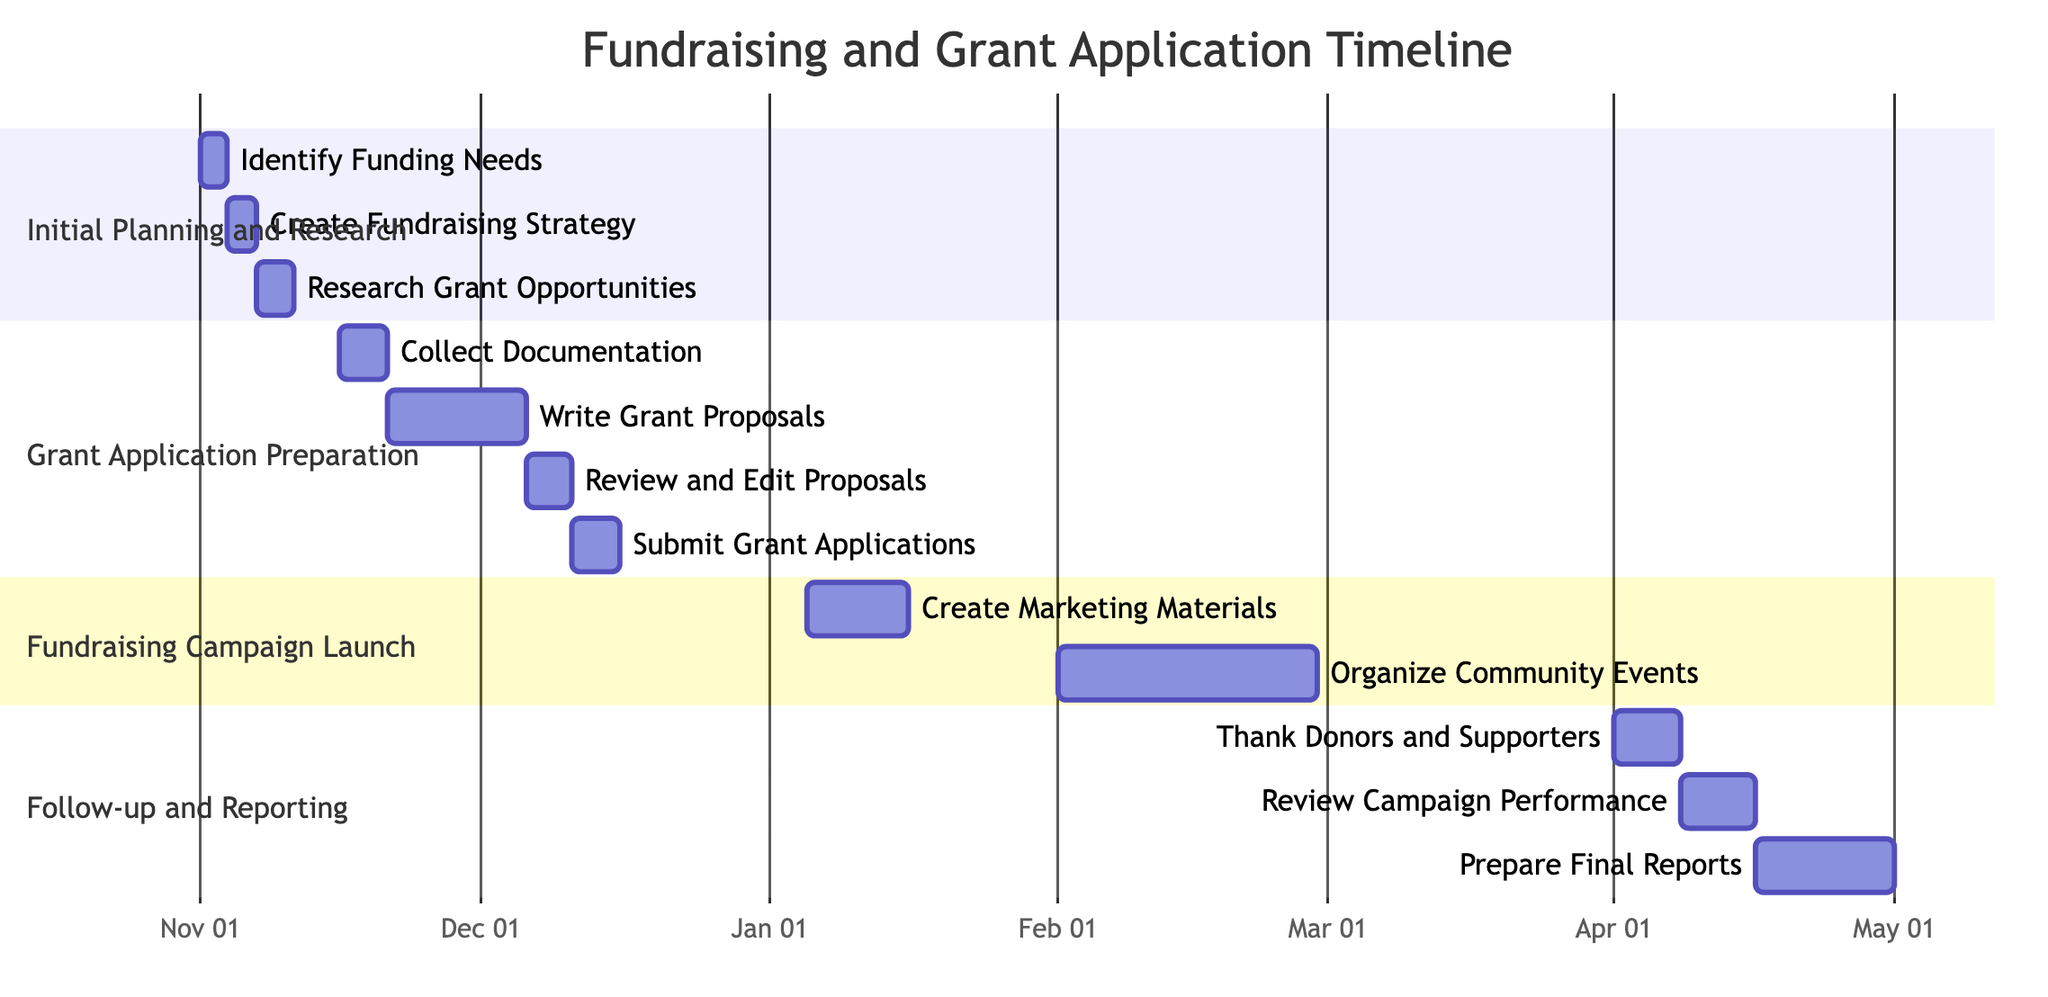What is the duration of the "Initial Planning and Research" milestone? The "Initial Planning and Research" milestone starts on November 1, 2023, and ends on November 15, 2023. Therefore, the duration is calculated as the number of days between these two dates, which is 15 days.
Answer: 15 days How many tasks are included in the "Grant Application Preparation" section? The "Grant Application Preparation" section has four tasks listed: Collect Necessary Documentation, Write Grant Proposals, Review and Edit Proposals, and Submit Grant Applications. By counting these tasks, we find that there are a total of four tasks.
Answer: 4 tasks What is the end date for "Organize Community Fundraising Events"? The task "Organize Community Fundraising Events" is scheduled to start on February 1, 2024, and ends on February 28, 2024. The end date can be directly seen from the information provided in the diagram.
Answer: February 28, 2024 Which task overlaps with the "Review and Edit Proposals"? The task "Review and Edit Proposals" occurs from December 6, 2023, to December 10, 2023. The task "Write Grant Proposals" starts on November 21, 2023, and ends on December 5, 2023, so it does not overlap. However, there is no overlap with other tasks since "Review and Edit Proposals" is the sole task in that timeframe. Therefore, it has no overlapping tasks.
Answer: None What is the first task in the "Fundraising Campaign Launch" milestone? The first task in the "Fundraising Campaign Launch" milestone is "Create Marketing Materials," which starts on January 5, 2024. By looking at the sequence of tasks within this section, it is clear that this is the first task listed.
Answer: Create Marketing Materials What are the dates for submitting grant applications? The task "Submit Grant Applications" occurs from December 11, 2023, to December 15, 2023. These dates are specified under the "Grant Application Preparation" section in the diagram, outlining the exact timing for this task.
Answer: December 11, 2023 - December 15, 2023 How many days does the "Thank Donors and Supporters" task take? The task "Thank Donors and Supporters" starts on April 1, 2024, and ends on April 7, 2024. To calculate the duration, count the number of days from the start to the end date, which totals 7 days.
Answer: 7 days What is the total duration of the "Follow-up and Reporting" section? The "Follow-up and Reporting" section runs from April 1, 2024, to April 30, 2024. To find the duration, count the number of days between these dates, which gives a total of 30 days in this section.
Answer: 30 days 